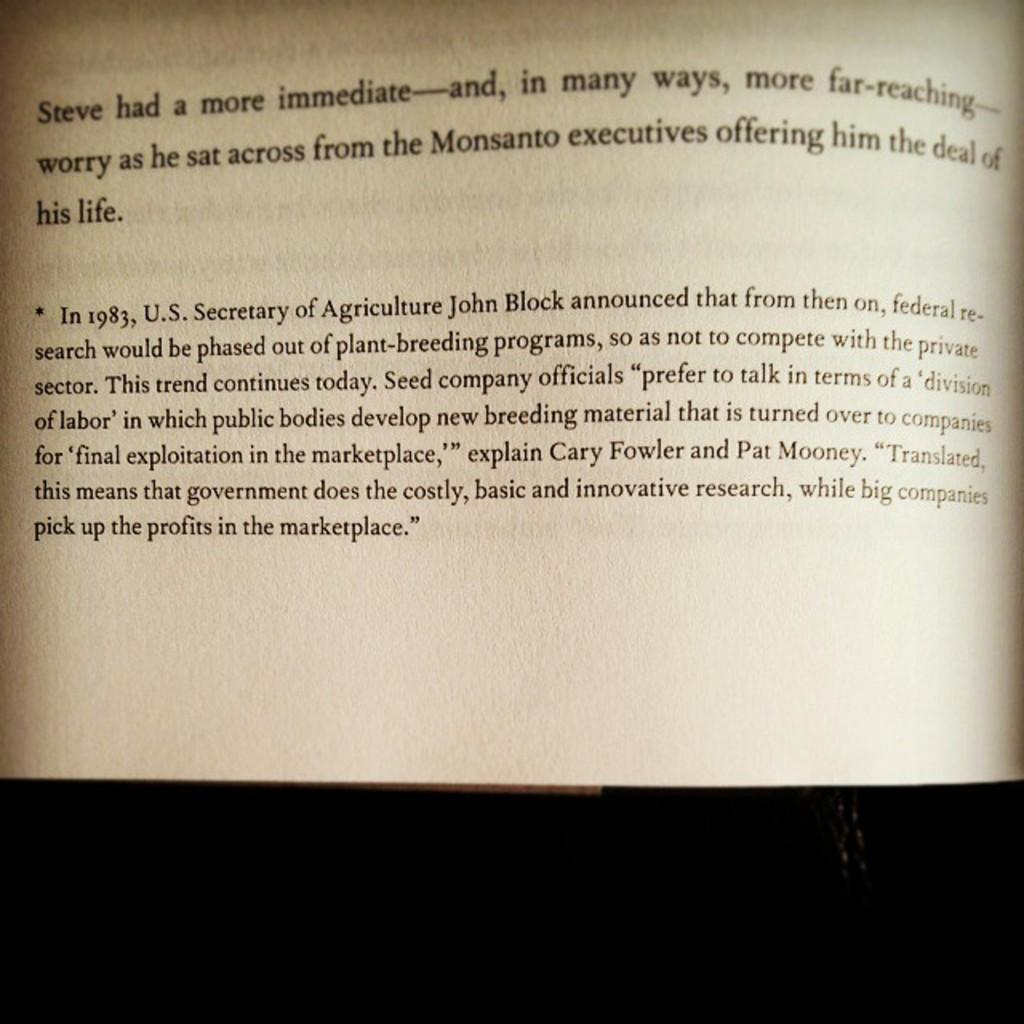Provide a one-sentence caption for the provided image. A book is open to a page discussing John Block and agriculture. 